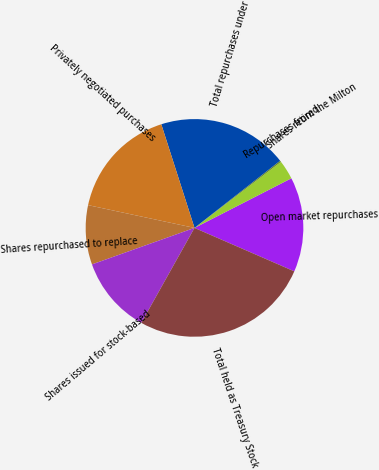Convert chart to OTSL. <chart><loc_0><loc_0><loc_500><loc_500><pie_chart><fcel>Open market repurchases<fcel>Repurchases from the Milton<fcel>Shares retired<fcel>Total repurchases under<fcel>Privately negotiated purchases<fcel>Shares repurchased to replace<fcel>Shares issued for stock-based<fcel>Total held as Treasury Stock<nl><fcel>14.07%<fcel>2.84%<fcel>0.21%<fcel>19.35%<fcel>16.71%<fcel>8.8%<fcel>11.43%<fcel>26.59%<nl></chart> 